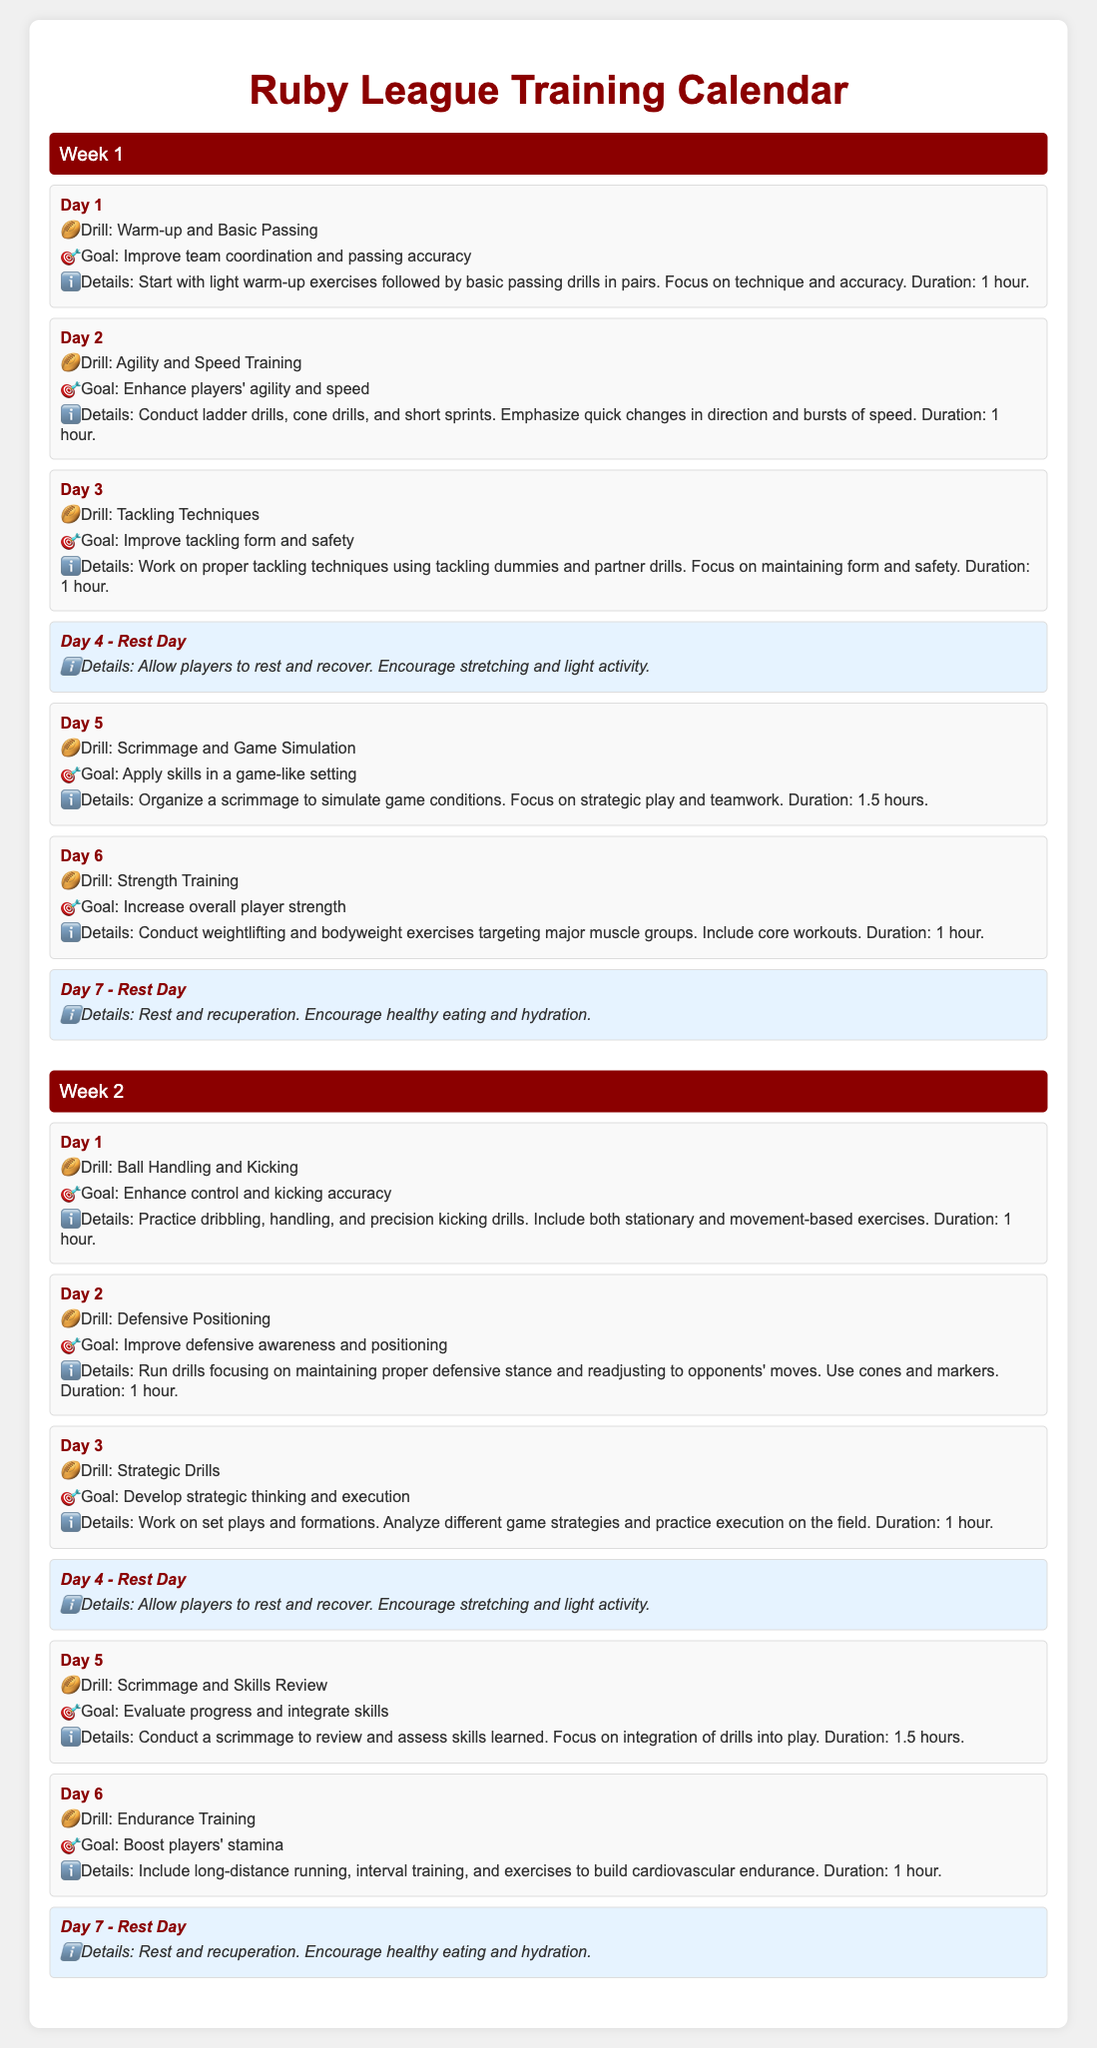What is the title of the document? The title of the document, as indicated at the top, is the main heading of the page.
Answer: Ruby League Training Calendar What is the goal of Day 1 in Week 1? The goal of Day 1 is listed under the corresponding drill for that day.
Answer: Improve team coordination and passing accuracy How long is the training duration for tackling techniques? The duration for the tackling techniques drill is specified in the details section of Day 3.
Answer: 1 hour How many rest days are there in Week 1? The rest days can be counted by examining the days labeled 'Rest Day'.
Answer: 2 What is the drill on Day 2 of Week 2? The drill for Day 2 is stated under that day in the weekly schedule.
Answer: Defensive Positioning Which week includes endurance training? The week that includes endurance training can be found in the respective section of the schedule.
Answer: Week 2 What type of drills are practiced on Day 5 in Week 1? The types of drills practiced on Day 5 are listed in the corresponding section of the day.
Answer: Scrimmage and Game Simulation What is emphasized during agility and speed training? The focus mentioned in the details for that day's drill outlines what is emphasized.
Answer: Quick changes in direction and bursts of speed How many days of training are listed in Week 2? The total number of training days can be determined by counting the individual training days in that week.
Answer: 5 